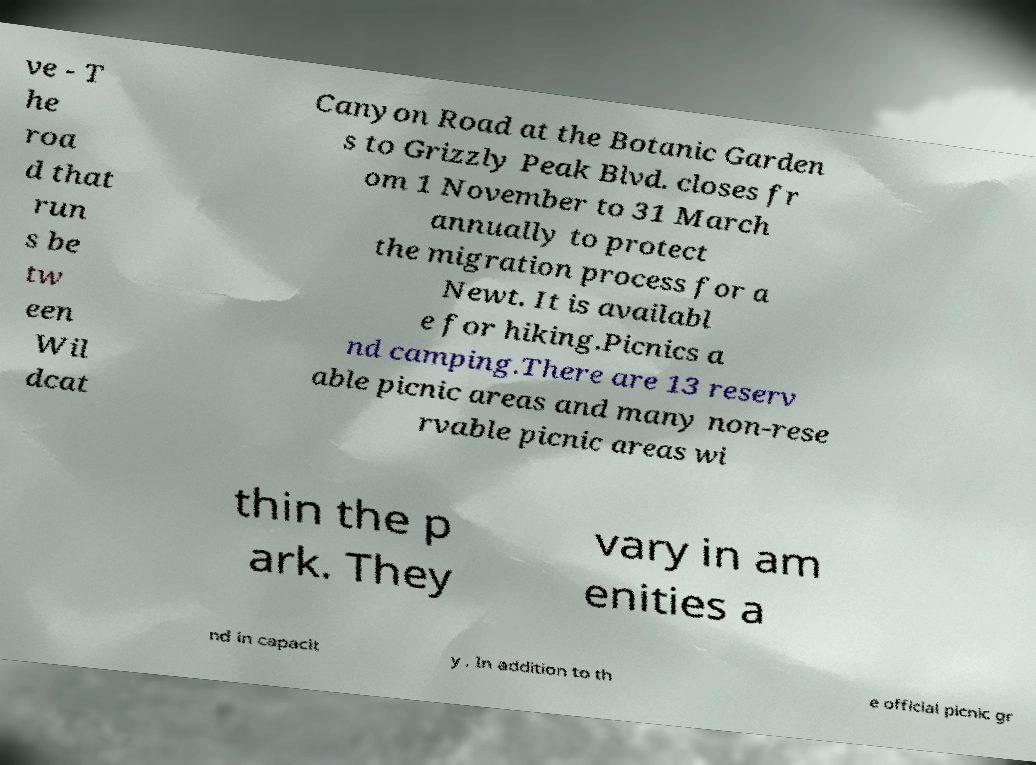Can you accurately transcribe the text from the provided image for me? ve - T he roa d that run s be tw een Wil dcat Canyon Road at the Botanic Garden s to Grizzly Peak Blvd. closes fr om 1 November to 31 March annually to protect the migration process for a Newt. It is availabl e for hiking.Picnics a nd camping.There are 13 reserv able picnic areas and many non-rese rvable picnic areas wi thin the p ark. They vary in am enities a nd in capacit y . In addition to th e official picnic gr 